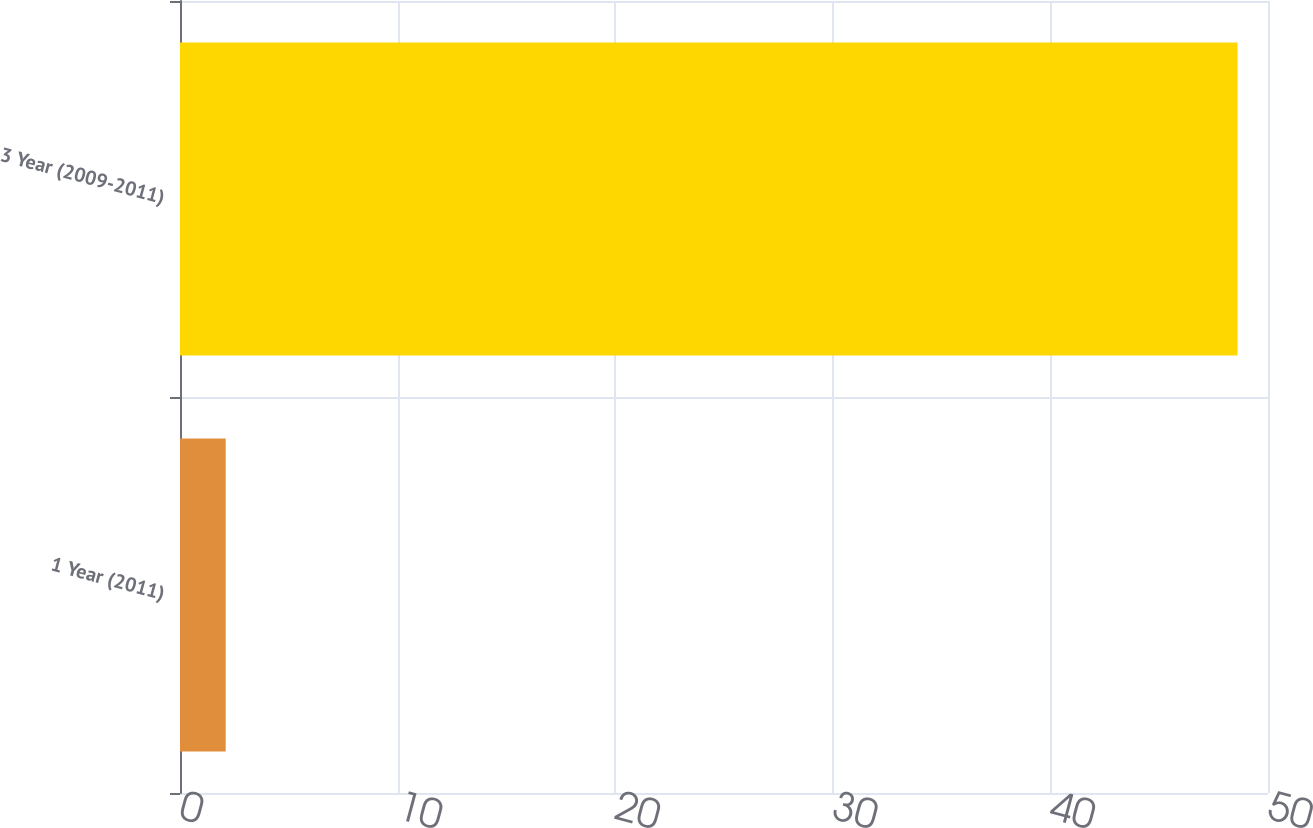Convert chart to OTSL. <chart><loc_0><loc_0><loc_500><loc_500><bar_chart><fcel>1 Year (2011)<fcel>3 Year (2009-2011)<nl><fcel>2.1<fcel>48.6<nl></chart> 